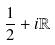Convert formula to latex. <formula><loc_0><loc_0><loc_500><loc_500>\frac { 1 } { 2 } + i \mathbb { R }</formula> 